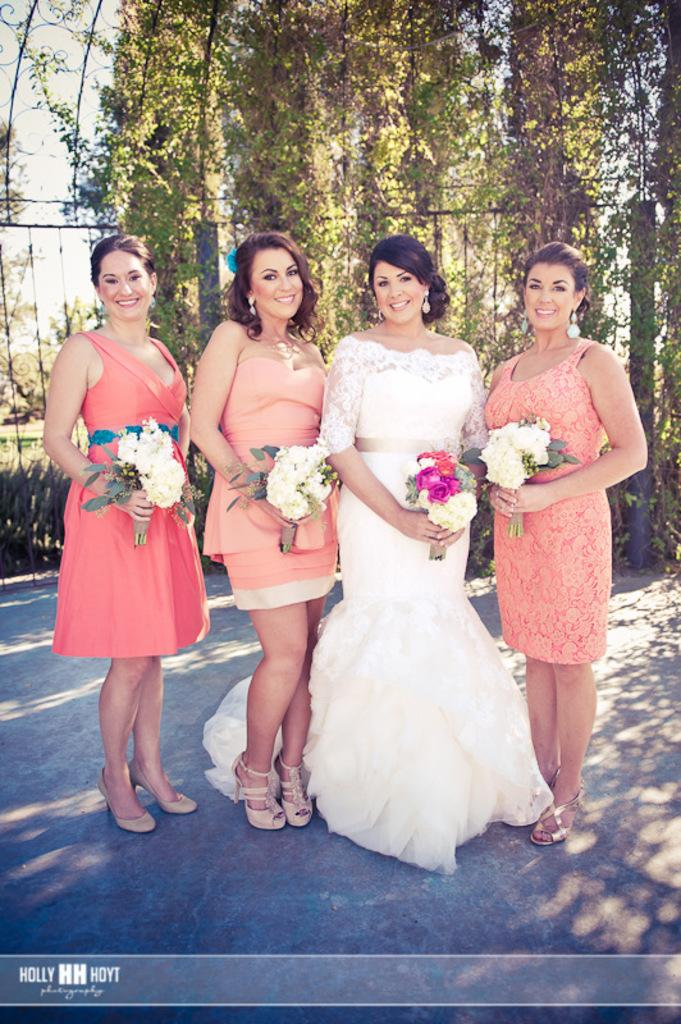What are the women in the image doing? The women in the image are standing in the middle and smiling. What are the women holding in the image? The women are holding flowers in the image. What is located behind the women in the image? There is fencing behind the women, and trees are visible behind the fencing. What type of vegetation can be seen in the image? There are plants in the image, including trees. What type of curtain can be seen hanging from the box in the image? There is no box or curtain present in the image. 